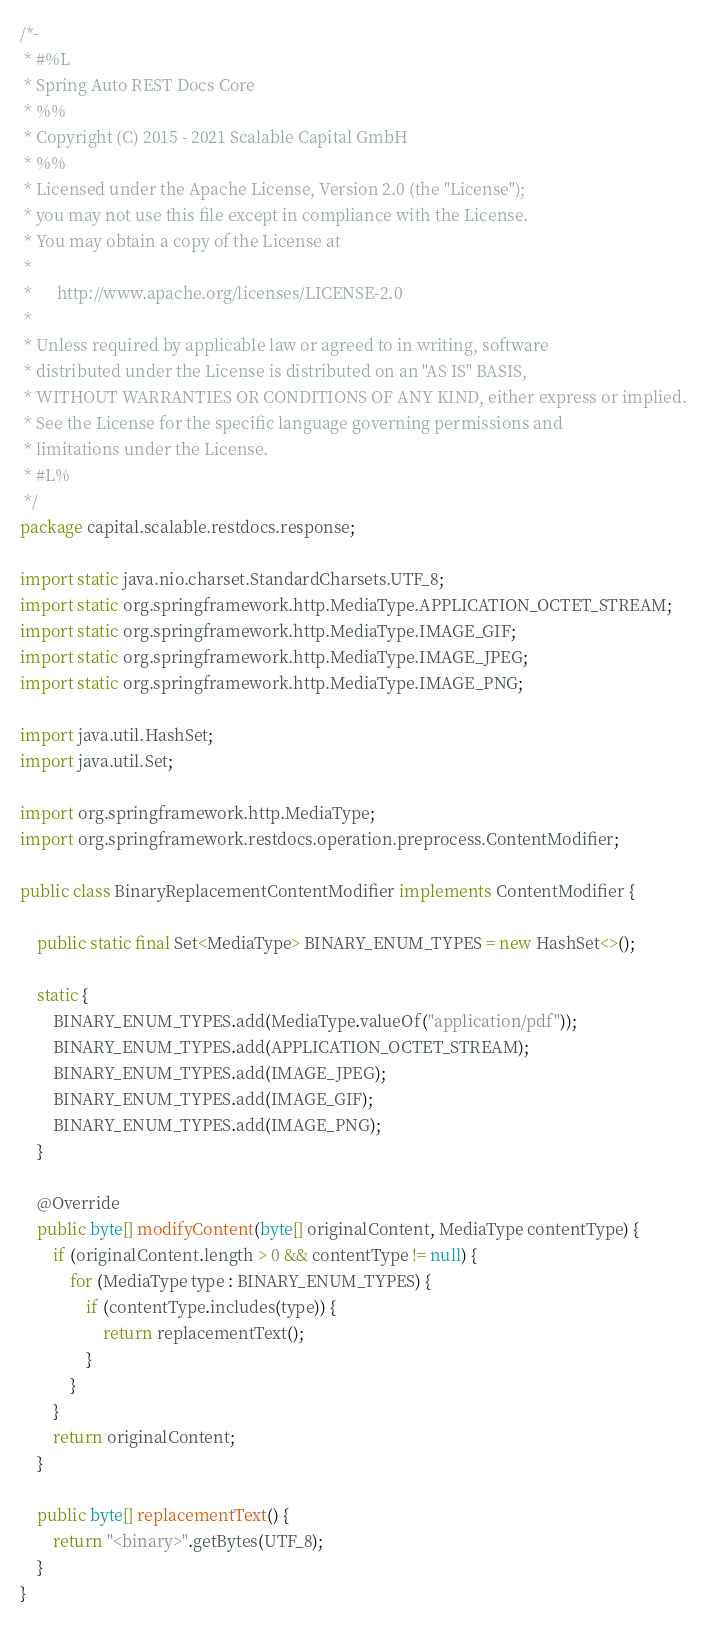<code> <loc_0><loc_0><loc_500><loc_500><_Java_>/*-
 * #%L
 * Spring Auto REST Docs Core
 * %%
 * Copyright (C) 2015 - 2021 Scalable Capital GmbH
 * %%
 * Licensed under the Apache License, Version 2.0 (the "License");
 * you may not use this file except in compliance with the License.
 * You may obtain a copy of the License at
 *
 *      http://www.apache.org/licenses/LICENSE-2.0
 *
 * Unless required by applicable law or agreed to in writing, software
 * distributed under the License is distributed on an "AS IS" BASIS,
 * WITHOUT WARRANTIES OR CONDITIONS OF ANY KIND, either express or implied.
 * See the License for the specific language governing permissions and
 * limitations under the License.
 * #L%
 */
package capital.scalable.restdocs.response;

import static java.nio.charset.StandardCharsets.UTF_8;
import static org.springframework.http.MediaType.APPLICATION_OCTET_STREAM;
import static org.springframework.http.MediaType.IMAGE_GIF;
import static org.springframework.http.MediaType.IMAGE_JPEG;
import static org.springframework.http.MediaType.IMAGE_PNG;

import java.util.HashSet;
import java.util.Set;

import org.springframework.http.MediaType;
import org.springframework.restdocs.operation.preprocess.ContentModifier;

public class BinaryReplacementContentModifier implements ContentModifier {

    public static final Set<MediaType> BINARY_ENUM_TYPES = new HashSet<>();

    static {
        BINARY_ENUM_TYPES.add(MediaType.valueOf("application/pdf"));
        BINARY_ENUM_TYPES.add(APPLICATION_OCTET_STREAM);
        BINARY_ENUM_TYPES.add(IMAGE_JPEG);
        BINARY_ENUM_TYPES.add(IMAGE_GIF);
        BINARY_ENUM_TYPES.add(IMAGE_PNG);
    }

    @Override
    public byte[] modifyContent(byte[] originalContent, MediaType contentType) {
        if (originalContent.length > 0 && contentType != null) {
            for (MediaType type : BINARY_ENUM_TYPES) {
                if (contentType.includes(type)) {
                    return replacementText();
                }
            }
        }
        return originalContent;
    }

    public byte[] replacementText() {
        return "<binary>".getBytes(UTF_8);
    }
}
</code> 